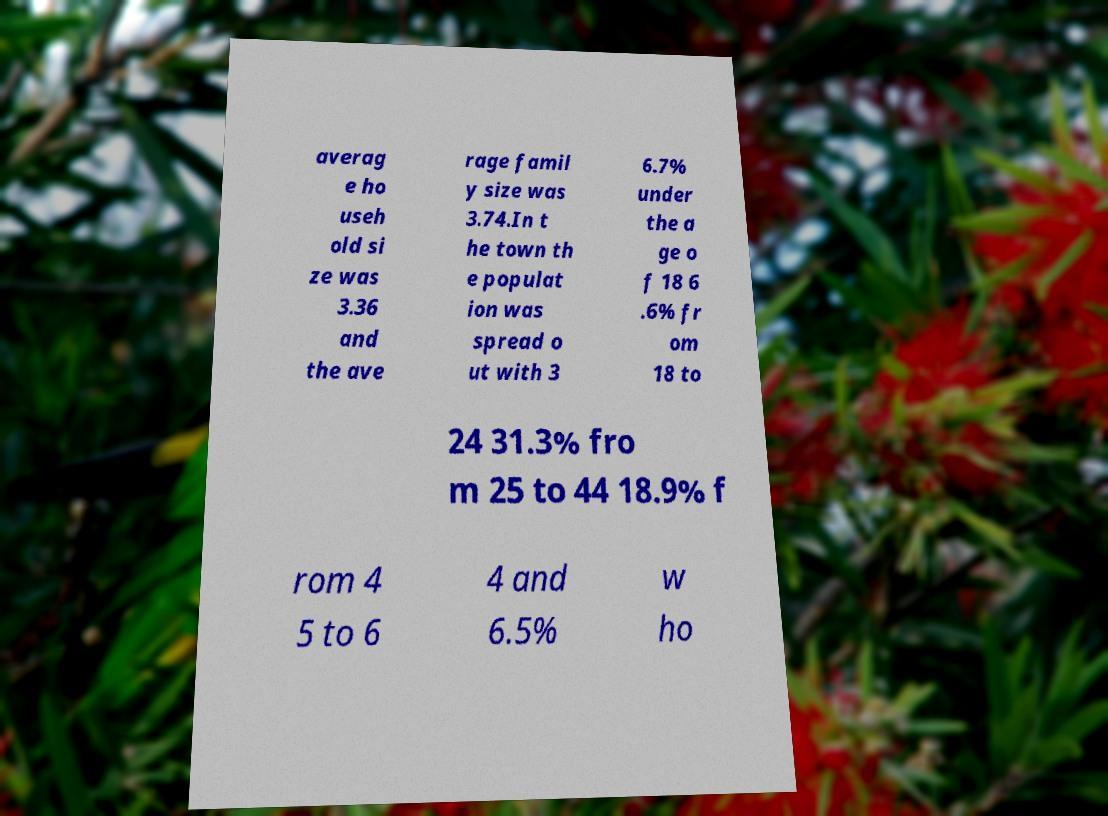Please identify and transcribe the text found in this image. averag e ho useh old si ze was 3.36 and the ave rage famil y size was 3.74.In t he town th e populat ion was spread o ut with 3 6.7% under the a ge o f 18 6 .6% fr om 18 to 24 31.3% fro m 25 to 44 18.9% f rom 4 5 to 6 4 and 6.5% w ho 